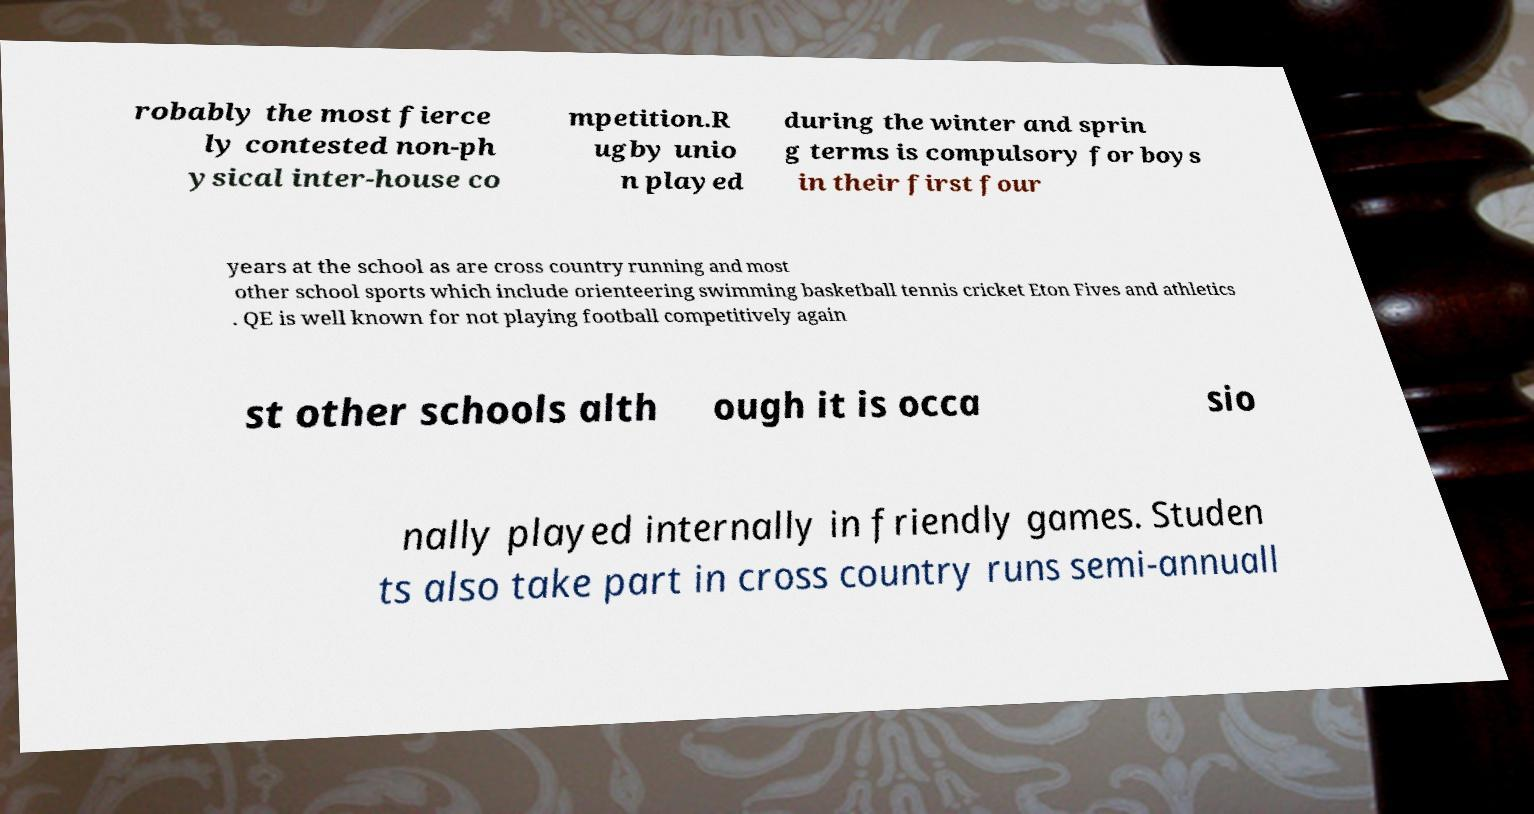What messages or text are displayed in this image? I need them in a readable, typed format. robably the most fierce ly contested non-ph ysical inter-house co mpetition.R ugby unio n played during the winter and sprin g terms is compulsory for boys in their first four years at the school as are cross country running and most other school sports which include orienteering swimming basketball tennis cricket Eton Fives and athletics . QE is well known for not playing football competitively again st other schools alth ough it is occa sio nally played internally in friendly games. Studen ts also take part in cross country runs semi-annuall 